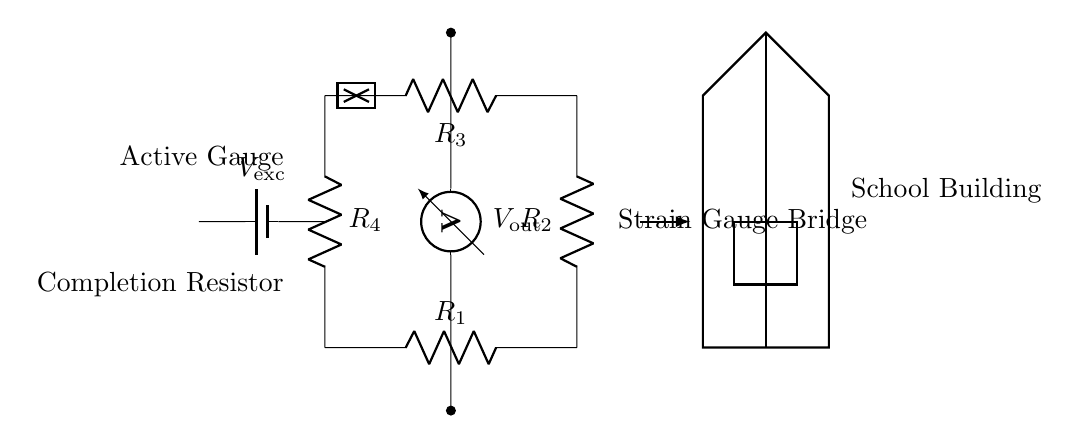What type of circuit is depicted? The circuit is a strain gauge bridge circuit designed for monitoring structural integrity. A strain gauge measures deformations, and the bridge configuration allows for high sensitivity in detecting changes.
Answer: strain gauge bridge What is the power source labeled in the circuit? The power source in this circuit is labeled as V_ex (excitation voltage). It provides the necessary voltage for the operation of the strain gauge bridge, facilitating the measurement of strain.
Answer: V_ex How many resistors are in this bridge circuit? The bridge circuit includes four resistors labeled R1, R2, R3, and R4, each contributing to the balance of the bridge. Their values can vary to adjust sensitivity for the application.
Answer: four What is the purpose of the voltmeter in the circuit? The voltmeter measures the output voltage (V_out) generated by the bridge due to any changes in resistance caused by strain. This voltage correlates with the strain experienced by the active gauge in the structure.
Answer: measure output voltage Which resistor is specifically indicated as the active gauge? The active gauge is represented as the resistor R1 in the circuit. It directly reacts to strain and alters its resistance, impacting the overall output voltage of the bridge.
Answer: R1 What does the building symbol represent in this circuit? The building symbol represents the school building being monitored for structural integrity. This connects the purpose of the strain gauge circuit to its application in ensuring safety in the school environment.
Answer: school building 